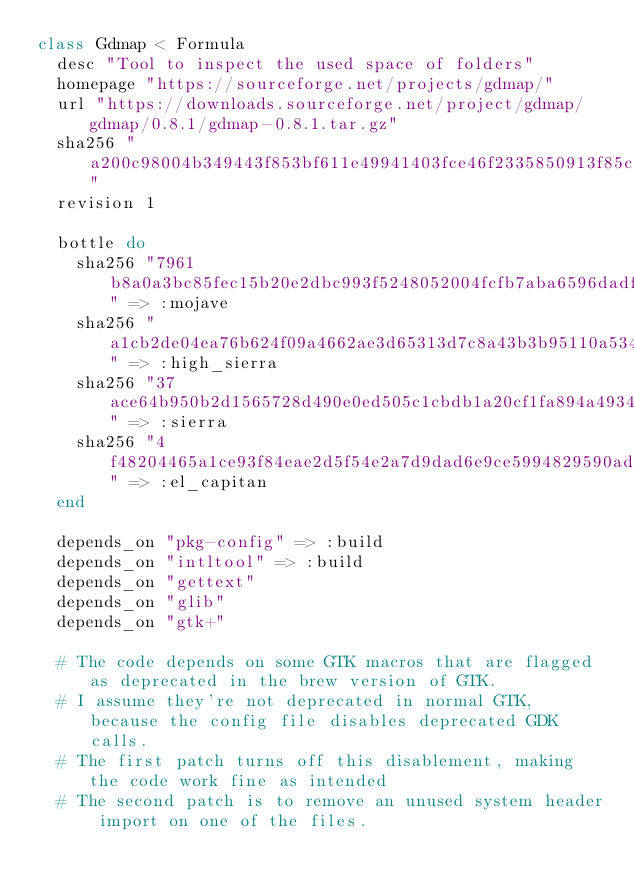Convert code to text. <code><loc_0><loc_0><loc_500><loc_500><_Ruby_>class Gdmap < Formula
  desc "Tool to inspect the used space of folders"
  homepage "https://sourceforge.net/projects/gdmap/"
  url "https://downloads.sourceforge.net/project/gdmap/gdmap/0.8.1/gdmap-0.8.1.tar.gz"
  sha256 "a200c98004b349443f853bf611e49941403fce46f2335850913f85c710a2285b"
  revision 1

  bottle do
    sha256 "7961b8a0a3bc85fec15b20e2dbc993f5248052004fcfb7aba6596dadfb0f6859" => :mojave
    sha256 "a1cb2de04ea76b624f09a4662ae3d65313d7c8a43b3b95110a53429af8cad2b2" => :high_sierra
    sha256 "37ace64b950b2d1565728d490e0ed505c1cbdb1a20cf1fa894a4934784a83a18" => :sierra
    sha256 "4f48204465a1ce93f84eae2d5f54e2a7d9dad6e9ce5994829590ad14d3640914" => :el_capitan
  end

  depends_on "pkg-config" => :build
  depends_on "intltool" => :build
  depends_on "gettext"
  depends_on "glib"
  depends_on "gtk+"

  # The code depends on some GTK macros that are flagged as deprecated in the brew version of GTK.
  # I assume they're not deprecated in normal GTK, because the config file disables deprecated GDK calls.
  # The first patch turns off this disablement, making the code work fine as intended
  # The second patch is to remove an unused system header import on one of the files.</code> 